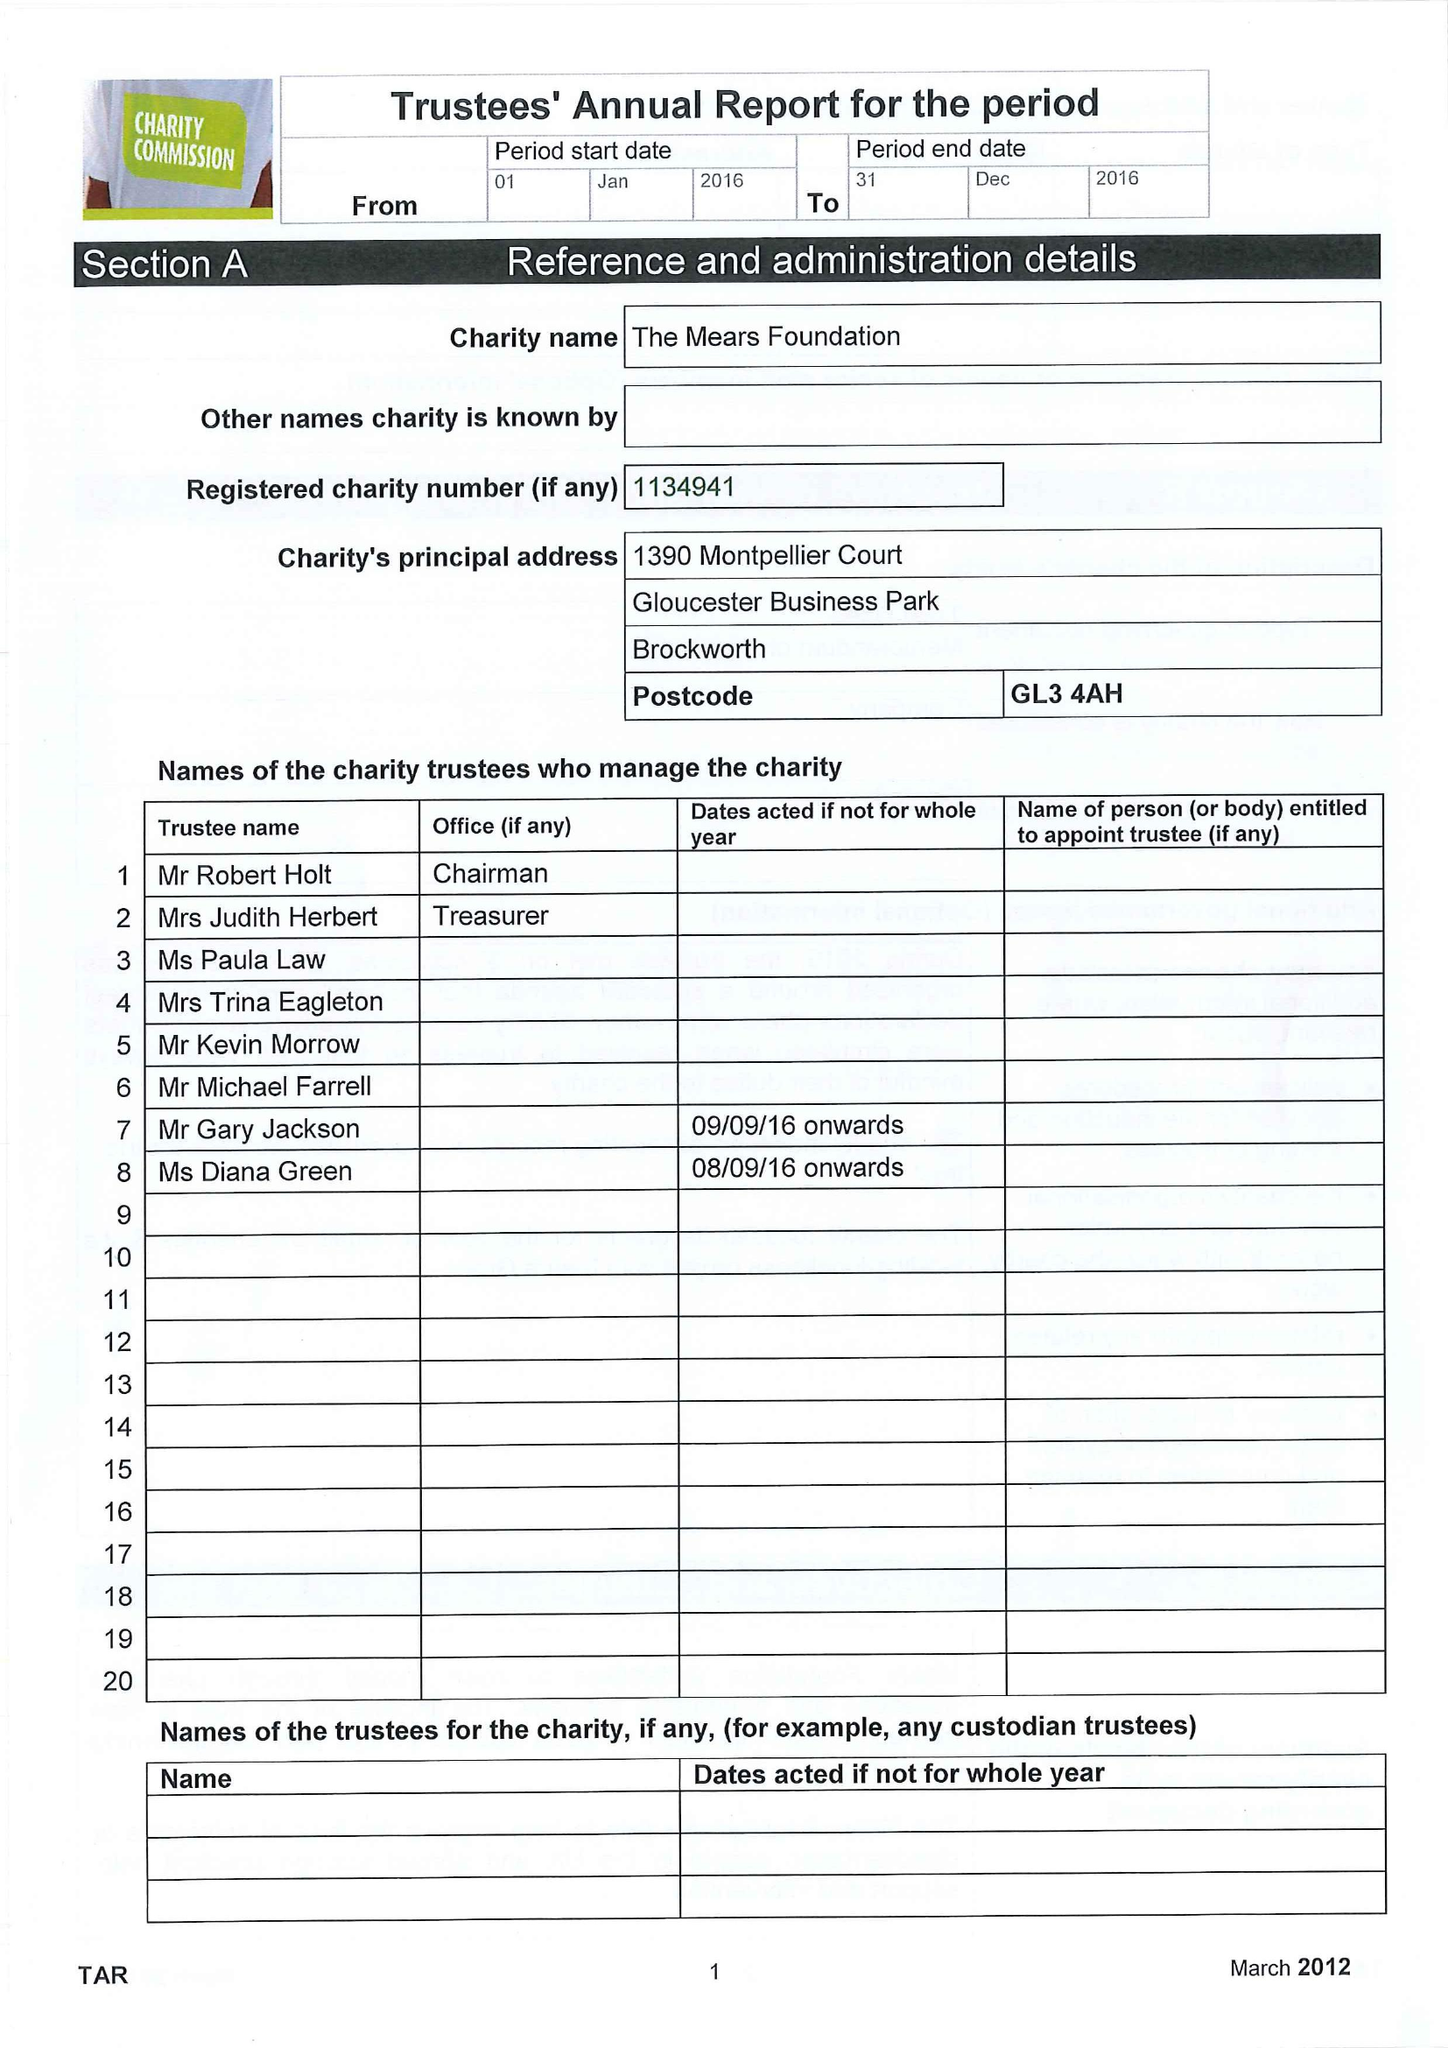What is the value for the address__street_line?
Answer the question using a single word or phrase. None 